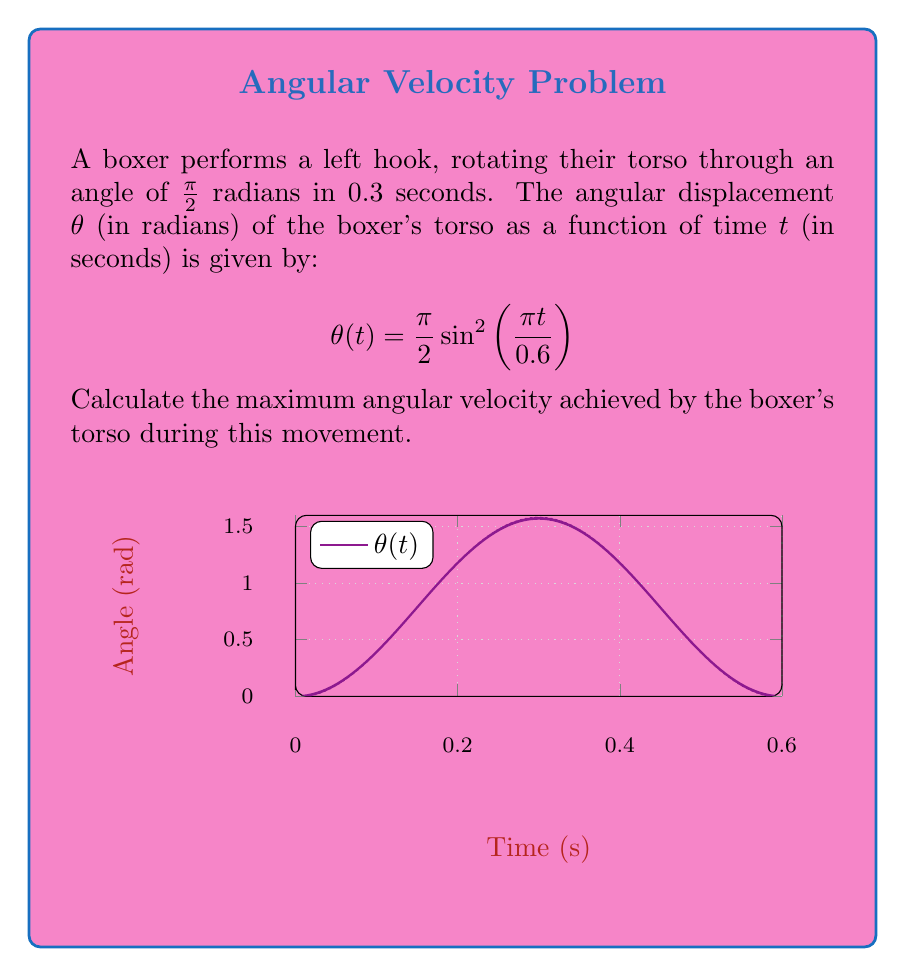Provide a solution to this math problem. Let's approach this step-by-step:

1) The angular velocity is the derivative of the angular displacement with respect to time. So, we need to find $\frac{d\theta}{dt}$.

2) Using the chain rule, we get:

   $$\frac{d\theta}{dt} = \frac{\pi}{2} \cdot 2\sin\left(\frac{\pi t}{0.6}\right)\cos\left(\frac{\pi t}{0.6}\right) \cdot \frac{\pi}{0.6}$$

3) Simplify:

   $$\frac{d\theta}{dt} = \frac{\pi^2}{1.2} \sin\left(\frac{\pi t}{0.3}\right)$$

4) To find the maximum angular velocity, we need to find the maximum value of this function.

5) The sine function reaches its maximum value of 1 when its argument is $\frac{\pi}{2}$.

6) So, the maximum angular velocity occurs when:

   $$\frac{\pi t}{0.3} = \frac{\pi}{2}$$

   $$t = 0.15 \text{ seconds}$$

7) The maximum value of the angular velocity is therefore:

   $$\left.\frac{d\theta}{dt}\right|_\text{max} = \frac{\pi^2}{1.2} = \frac{\pi^2}{1.2} \approx 8.2 \text{ rad/s}$$
Answer: $\frac{\pi^2}{1.2}$ rad/s 